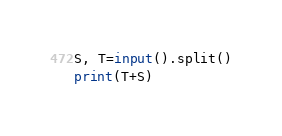Convert code to text. <code><loc_0><loc_0><loc_500><loc_500><_Python_>S, T=input().split()
print(T+S)</code> 